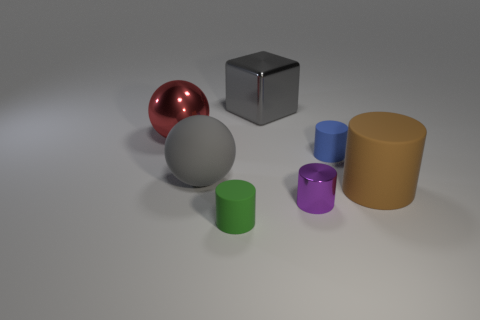Subtract all brown matte cylinders. How many cylinders are left? 3 Subtract all blue cylinders. How many cylinders are left? 3 Subtract 1 cylinders. How many cylinders are left? 3 Add 3 big gray blocks. How many objects exist? 10 Subtract all yellow cylinders. Subtract all cyan cubes. How many cylinders are left? 4 Subtract all spheres. How many objects are left? 5 Subtract all cubes. Subtract all tiny cylinders. How many objects are left? 3 Add 7 blue rubber things. How many blue rubber things are left? 8 Add 3 purple cylinders. How many purple cylinders exist? 4 Subtract 0 gray cylinders. How many objects are left? 7 